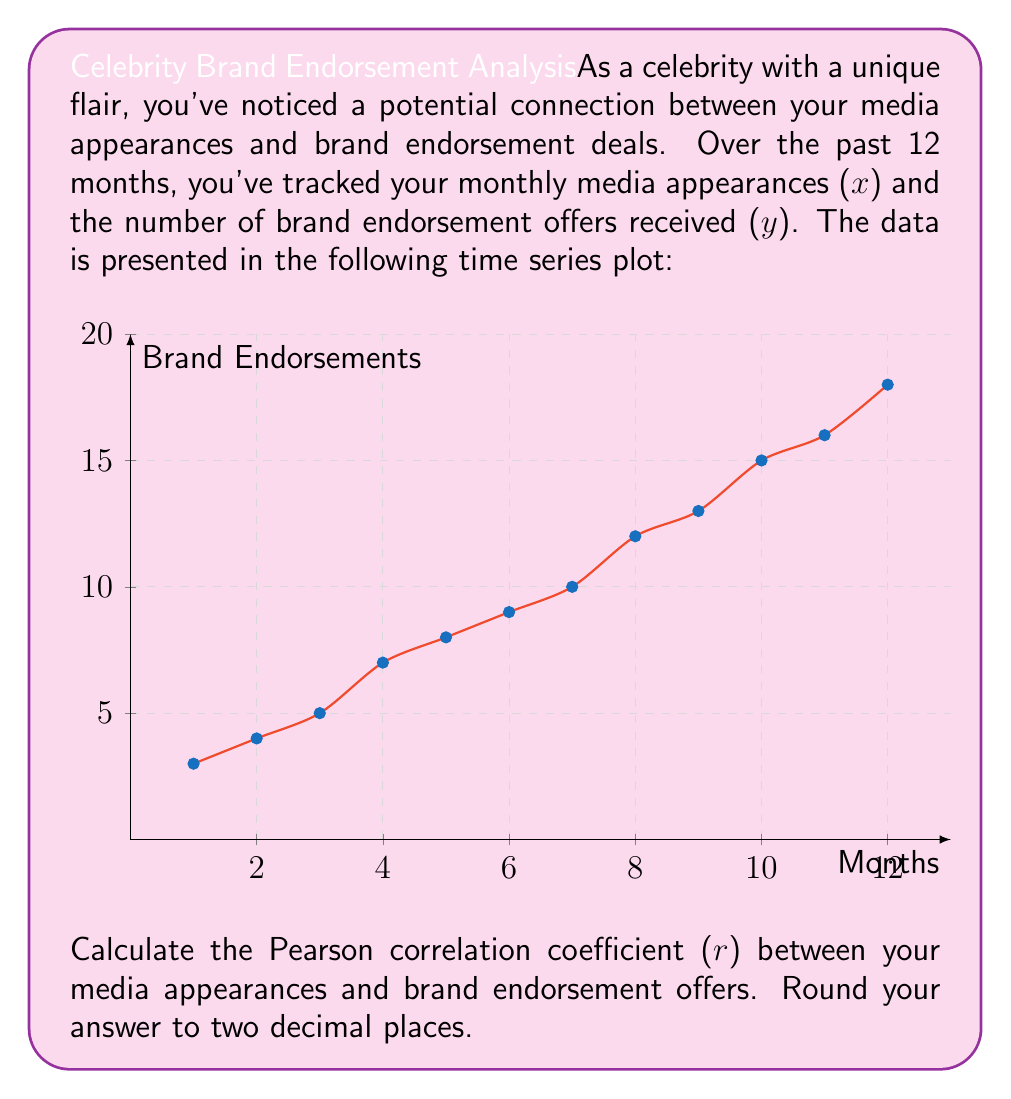Provide a solution to this math problem. To calculate the Pearson correlation coefficient (r), we'll follow these steps:

1. Calculate the means of x (media appearances) and y (brand endorsements):
   $$\bar{x} = \frac{\sum_{i=1}^{12} x_i}{12} = \frac{1+2+3+...+12}{12} = 6.5$$
   $$\bar{y} = \frac{\sum_{i=1}^{12} y_i}{12} = \frac{3+4+5+...+18}{12} = 10$$

2. Calculate the deviations from the mean for both x and y:
   $x_i - \bar{x}$ and $y_i - \bar{y}$

3. Calculate the products of these deviations:
   $(x_i - \bar{x})(y_i - \bar{y})$

4. Sum up these products:
   $$\sum_{i=1}^{12} (x_i - \bar{x})(y_i - \bar{y}) = 143$$

5. Calculate the sum of squared deviations for x and y:
   $$\sum_{i=1}^{12} (x_i - \bar{x})^2 = 143$$
   $$\sum_{i=1}^{12} (y_i - \bar{y})^2 = 252$$

6. Apply the formula for Pearson correlation coefficient:
   $$r = \frac{\sum_{i=1}^{12} (x_i - \bar{x})(y_i - \bar{y})}{\sqrt{\sum_{i=1}^{12} (x_i - \bar{x})^2 \sum_{i=1}^{12} (y_i - \bar{y})^2}}$$

7. Substitute the values:
   $$r = \frac{143}{\sqrt{143 \times 252}} = \frac{143}{189.74} \approx 0.7537$$

8. Round to two decimal places:
   $r \approx 0.75$
Answer: 0.75 